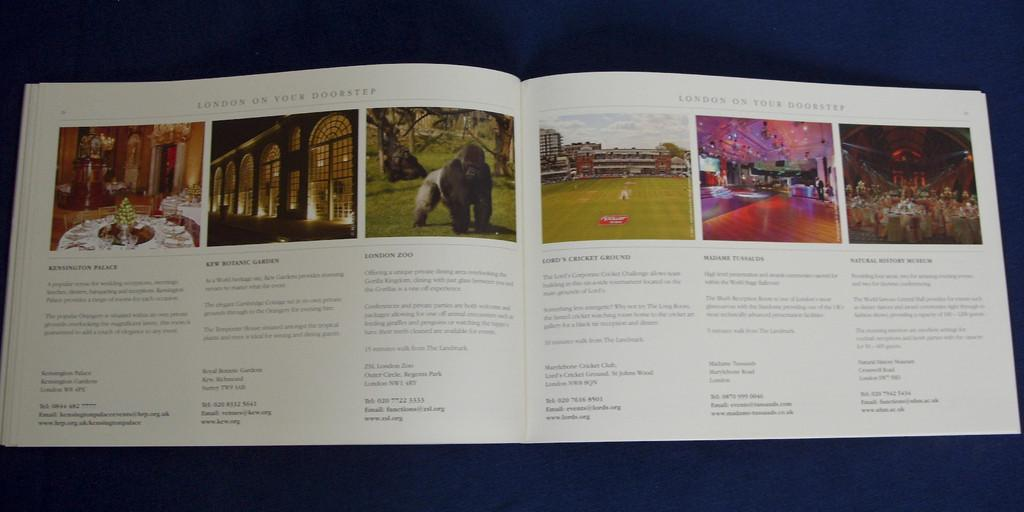Provide a one-sentence caption for the provided image. A book showcasing activities in London including zoos and historic locations. 